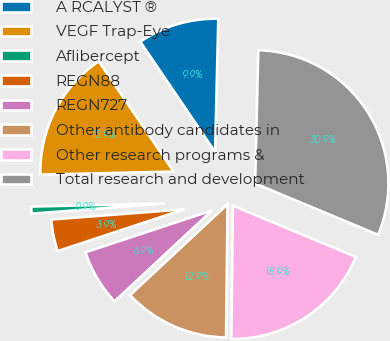Convert chart to OTSL. <chart><loc_0><loc_0><loc_500><loc_500><pie_chart><fcel>A RCALYST ®<fcel>VEGF Trap-Eye<fcel>Aflibercept<fcel>REGN88<fcel>REGN727<fcel>Other antibody candidates in<fcel>Other research programs &<fcel>Total research and development<nl><fcel>9.87%<fcel>15.88%<fcel>0.85%<fcel>3.86%<fcel>6.86%<fcel>12.88%<fcel>18.89%<fcel>30.91%<nl></chart> 